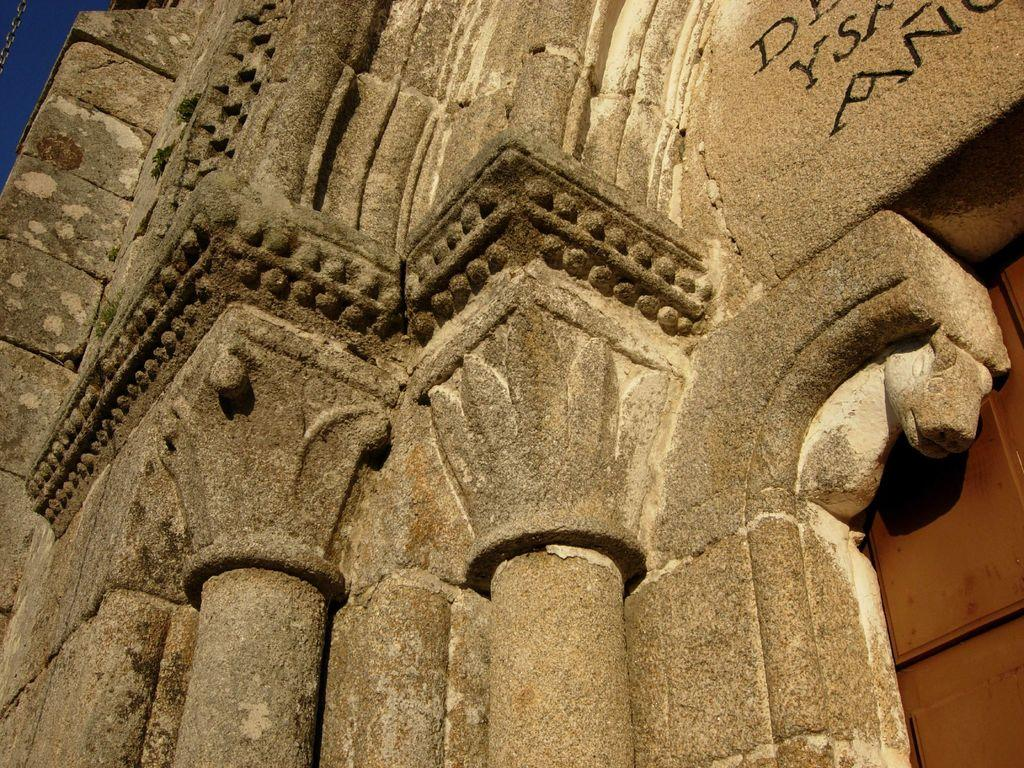What type of structure is the main subject of the image? There is a castle in the image. What other objects can be seen in the image? There are poles and a stone carved statue in the image. Can you describe the right side of the image? There is a wall or door in brown color on the right side of the image. What is visible in the top left corner of the image? The sky is visible in the left top of the image. What flavor of ice cream is being served at the castle in the image? There is no ice cream present in the image, and the image does not depict any food or beverages. 